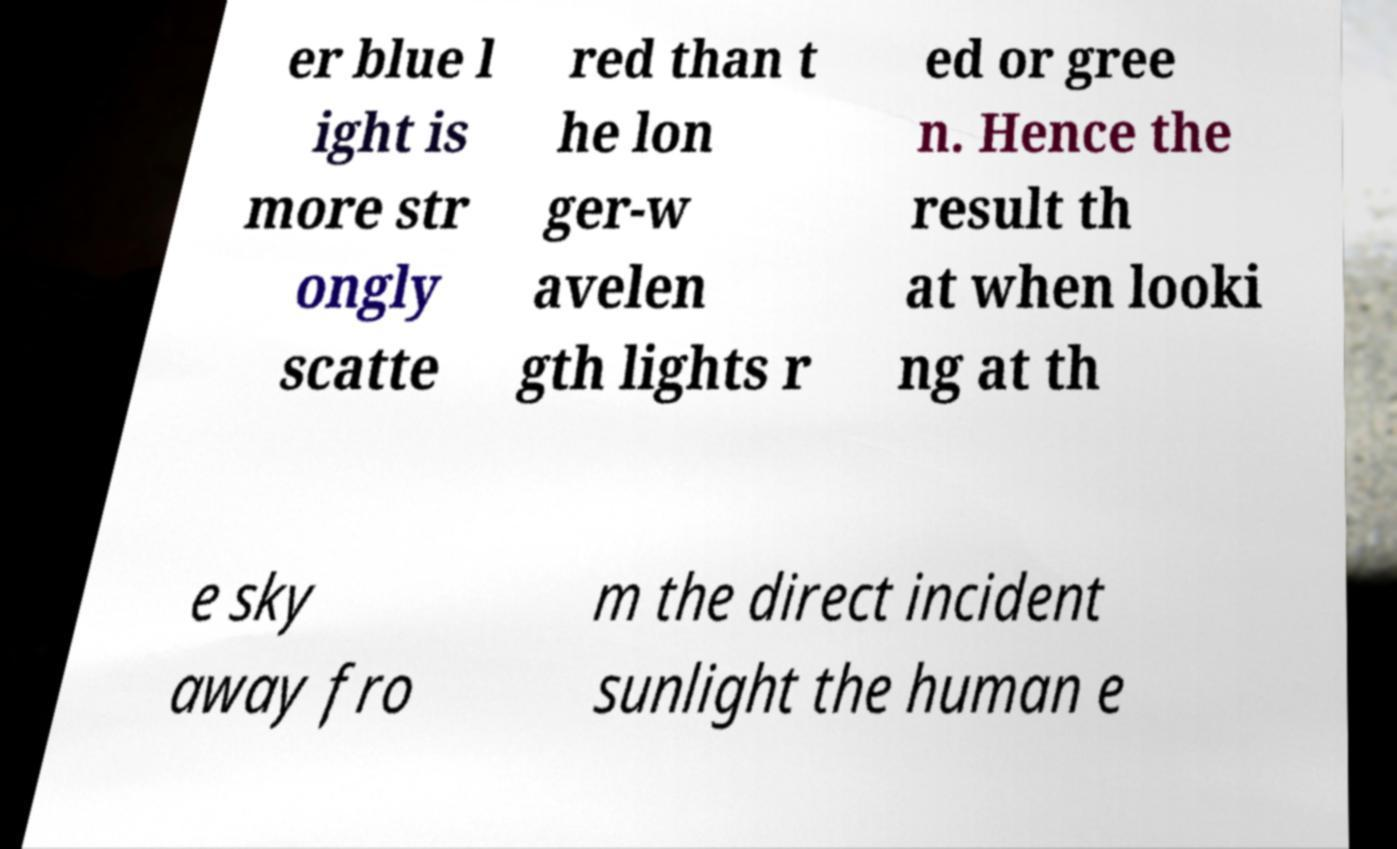Could you assist in decoding the text presented in this image and type it out clearly? er blue l ight is more str ongly scatte red than t he lon ger-w avelen gth lights r ed or gree n. Hence the result th at when looki ng at th e sky away fro m the direct incident sunlight the human e 